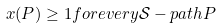Convert formula to latex. <formula><loc_0><loc_0><loc_500><loc_500>x ( P ) \geq 1 f o r e v e r y { \mathcal { S } } - p a t h P</formula> 